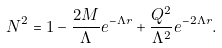<formula> <loc_0><loc_0><loc_500><loc_500>N ^ { 2 } = 1 - \frac { 2 M } { \Lambda } e ^ { - \Lambda r } + \frac { Q ^ { 2 } } { \Lambda ^ { 2 } } e ^ { - 2 \Lambda r } .</formula> 